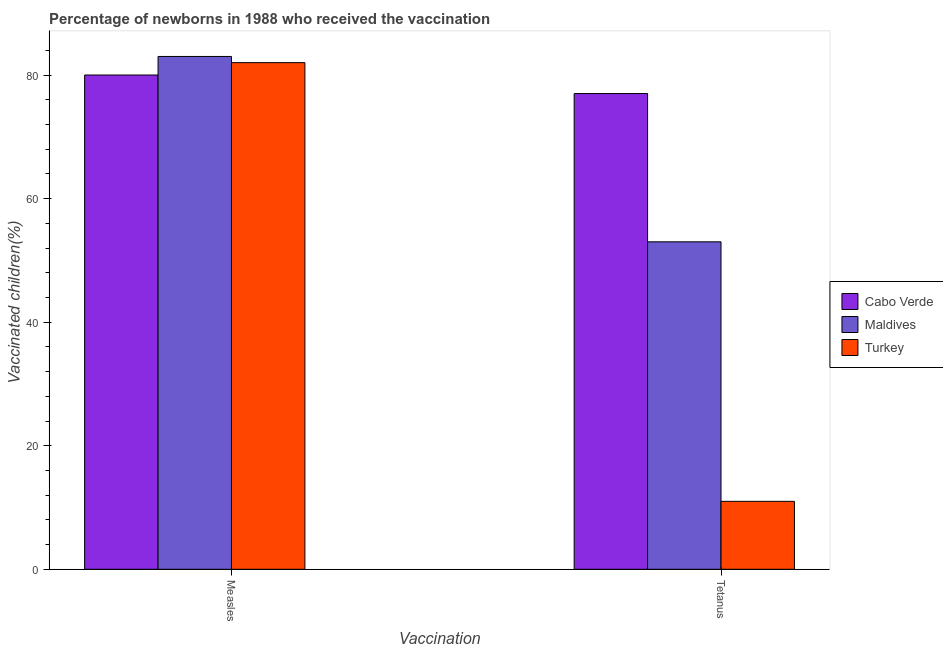How many different coloured bars are there?
Your answer should be compact. 3. Are the number of bars per tick equal to the number of legend labels?
Provide a short and direct response. Yes. How many bars are there on the 1st tick from the right?
Make the answer very short. 3. What is the label of the 1st group of bars from the left?
Give a very brief answer. Measles. What is the percentage of newborns who received vaccination for measles in Maldives?
Ensure brevity in your answer.  83. Across all countries, what is the maximum percentage of newborns who received vaccination for measles?
Provide a short and direct response. 83. Across all countries, what is the minimum percentage of newborns who received vaccination for tetanus?
Keep it short and to the point. 11. In which country was the percentage of newborns who received vaccination for measles maximum?
Keep it short and to the point. Maldives. In which country was the percentage of newborns who received vaccination for measles minimum?
Your answer should be very brief. Cabo Verde. What is the total percentage of newborns who received vaccination for measles in the graph?
Offer a very short reply. 245. What is the difference between the percentage of newborns who received vaccination for tetanus in Cabo Verde and that in Maldives?
Offer a terse response. 24. What is the difference between the percentage of newborns who received vaccination for tetanus in Cabo Verde and the percentage of newborns who received vaccination for measles in Turkey?
Offer a terse response. -5. What is the average percentage of newborns who received vaccination for tetanus per country?
Your answer should be compact. 47. What is the difference between the percentage of newborns who received vaccination for measles and percentage of newborns who received vaccination for tetanus in Maldives?
Offer a terse response. 30. In how many countries, is the percentage of newborns who received vaccination for tetanus greater than 64 %?
Your answer should be compact. 1. What is the ratio of the percentage of newborns who received vaccination for tetanus in Cabo Verde to that in Maldives?
Your answer should be compact. 1.45. Is the percentage of newborns who received vaccination for measles in Maldives less than that in Cabo Verde?
Provide a succinct answer. No. In how many countries, is the percentage of newborns who received vaccination for measles greater than the average percentage of newborns who received vaccination for measles taken over all countries?
Keep it short and to the point. 2. What does the 3rd bar from the right in Tetanus represents?
Your response must be concise. Cabo Verde. How many bars are there?
Your answer should be compact. 6. How many countries are there in the graph?
Your response must be concise. 3. What is the difference between two consecutive major ticks on the Y-axis?
Make the answer very short. 20. Does the graph contain any zero values?
Offer a very short reply. No. Does the graph contain grids?
Provide a short and direct response. No. Where does the legend appear in the graph?
Keep it short and to the point. Center right. How many legend labels are there?
Keep it short and to the point. 3. How are the legend labels stacked?
Keep it short and to the point. Vertical. What is the title of the graph?
Keep it short and to the point. Percentage of newborns in 1988 who received the vaccination. Does "Jordan" appear as one of the legend labels in the graph?
Offer a terse response. No. What is the label or title of the X-axis?
Provide a short and direct response. Vaccination. What is the label or title of the Y-axis?
Your answer should be compact. Vaccinated children(%)
. What is the Vaccinated children(%)
 in Cabo Verde in Measles?
Offer a terse response. 80. What is the Vaccinated children(%)
 in Maldives in Tetanus?
Ensure brevity in your answer.  53. What is the Vaccinated children(%)
 of Turkey in Tetanus?
Your answer should be very brief. 11. Across all Vaccination, what is the maximum Vaccinated children(%)
 in Maldives?
Make the answer very short. 83. Across all Vaccination, what is the maximum Vaccinated children(%)
 of Turkey?
Your response must be concise. 82. Across all Vaccination, what is the minimum Vaccinated children(%)
 in Cabo Verde?
Provide a short and direct response. 77. Across all Vaccination, what is the minimum Vaccinated children(%)
 of Maldives?
Your response must be concise. 53. Across all Vaccination, what is the minimum Vaccinated children(%)
 of Turkey?
Your answer should be compact. 11. What is the total Vaccinated children(%)
 of Cabo Verde in the graph?
Keep it short and to the point. 157. What is the total Vaccinated children(%)
 of Maldives in the graph?
Your answer should be compact. 136. What is the total Vaccinated children(%)
 in Turkey in the graph?
Offer a terse response. 93. What is the difference between the Vaccinated children(%)
 in Cabo Verde in Measles and that in Tetanus?
Your answer should be very brief. 3. What is the difference between the Vaccinated children(%)
 of Maldives in Measles and that in Tetanus?
Offer a terse response. 30. What is the difference between the Vaccinated children(%)
 of Turkey in Measles and that in Tetanus?
Give a very brief answer. 71. What is the average Vaccinated children(%)
 of Cabo Verde per Vaccination?
Your response must be concise. 78.5. What is the average Vaccinated children(%)
 in Turkey per Vaccination?
Provide a short and direct response. 46.5. What is the difference between the Vaccinated children(%)
 of Cabo Verde and Vaccinated children(%)
 of Maldives in Measles?
Offer a terse response. -3. What is the difference between the Vaccinated children(%)
 of Cabo Verde and Vaccinated children(%)
 of Turkey in Tetanus?
Make the answer very short. 66. What is the ratio of the Vaccinated children(%)
 in Cabo Verde in Measles to that in Tetanus?
Keep it short and to the point. 1.04. What is the ratio of the Vaccinated children(%)
 of Maldives in Measles to that in Tetanus?
Give a very brief answer. 1.57. What is the ratio of the Vaccinated children(%)
 of Turkey in Measles to that in Tetanus?
Offer a terse response. 7.45. What is the difference between the highest and the second highest Vaccinated children(%)
 of Cabo Verde?
Your answer should be compact. 3. What is the difference between the highest and the second highest Vaccinated children(%)
 in Maldives?
Your answer should be compact. 30. 